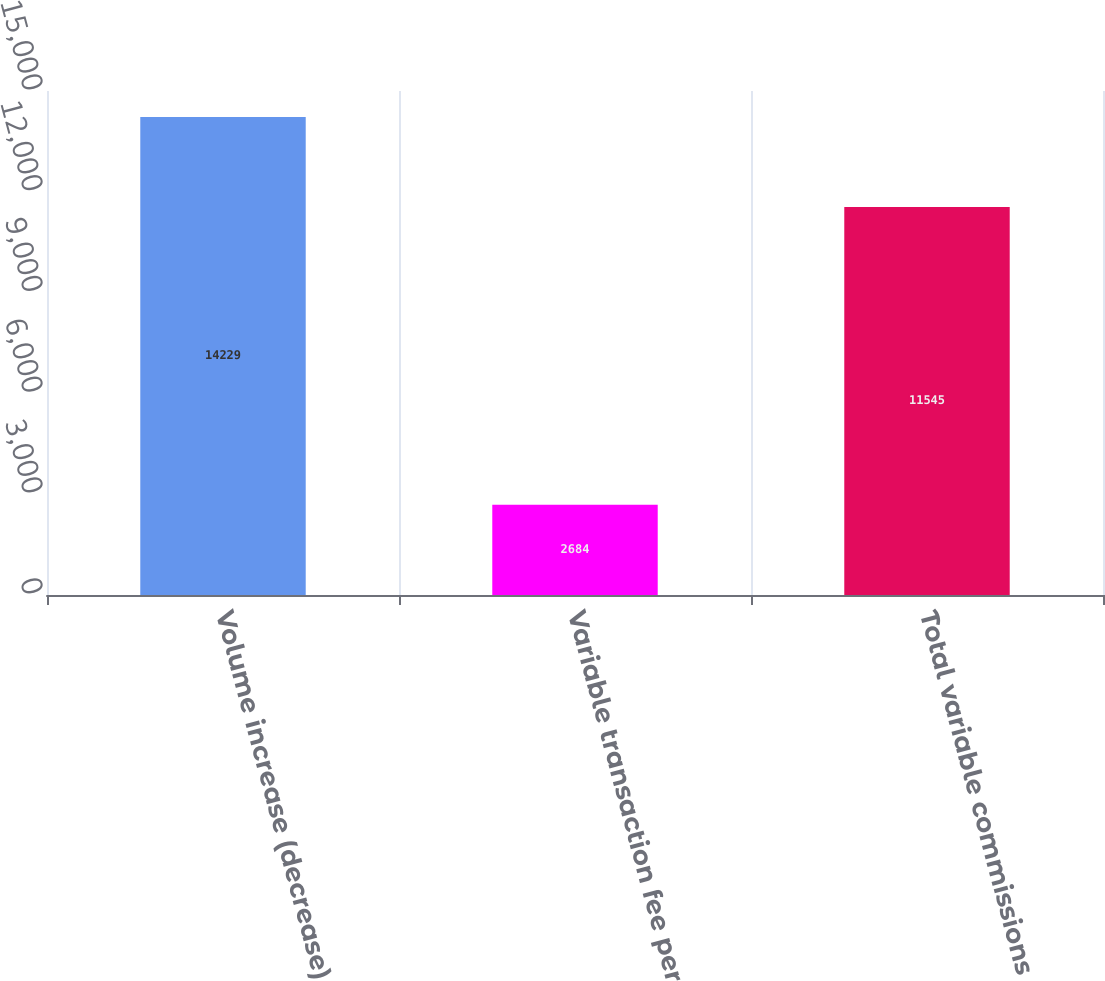Convert chart. <chart><loc_0><loc_0><loc_500><loc_500><bar_chart><fcel>Volume increase (decrease)<fcel>Variable transaction fee per<fcel>Total variable commissions<nl><fcel>14229<fcel>2684<fcel>11545<nl></chart> 